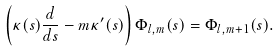Convert formula to latex. <formula><loc_0><loc_0><loc_500><loc_500>\left ( \kappa ( s ) \frac { d } { d s } - m \kappa ^ { \prime } ( s ) \right ) \Phi _ { l , m } ( s ) = \Phi _ { l , m + 1 } ( s ) .</formula> 